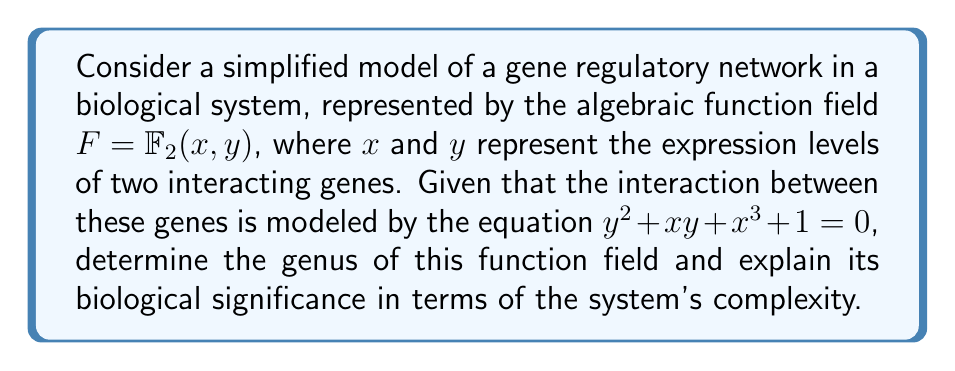Provide a solution to this math problem. To solve this problem, we'll follow these steps:

1) First, we need to recognize that the given equation defines a curve over the field $\mathbb{F}_2$. This curve is associated with the function field $F = \mathbb{F}_2(x,y)$.

2) To find the genus of the function field, we can use the genus formula for a plane curve:

   $$g = \frac{(d-1)(d-2)}{2}$$

   where $d$ is the degree of the curve.

3) In our case, the equation $y^2 + xy + x^3 + 1 = 0$ defines a curve of degree 3 (the highest degree term is $x^3$).

4) Substituting $d=3$ into the formula:

   $$g = \frac{(3-1)(3-2)}{2} = \frac{2 \cdot 1}{2} = 1$$

5) Therefore, the genus of the function field is 1.

6) Biological significance:
   - The genus of a function field is a measure of its complexity.
   - A genus of 1 indicates that this system has a moderate level of complexity.
   - In biological terms, this suggests that the gene regulatory network modeled by this function field has some non-trivial interactions, but is not excessively complex.
   - This level of complexity could indicate a system with feedback loops or multiple stable states, which are common features in gene regulatory networks.
   - For a family medicine practitioner, this could translate to a biological system that exhibits some adaptability and robustness, but is not so complex as to be unpredictable or unmanageable in a clinical setting.
Answer: The genus is 1, indicating moderate complexity in the gene regulatory network. 